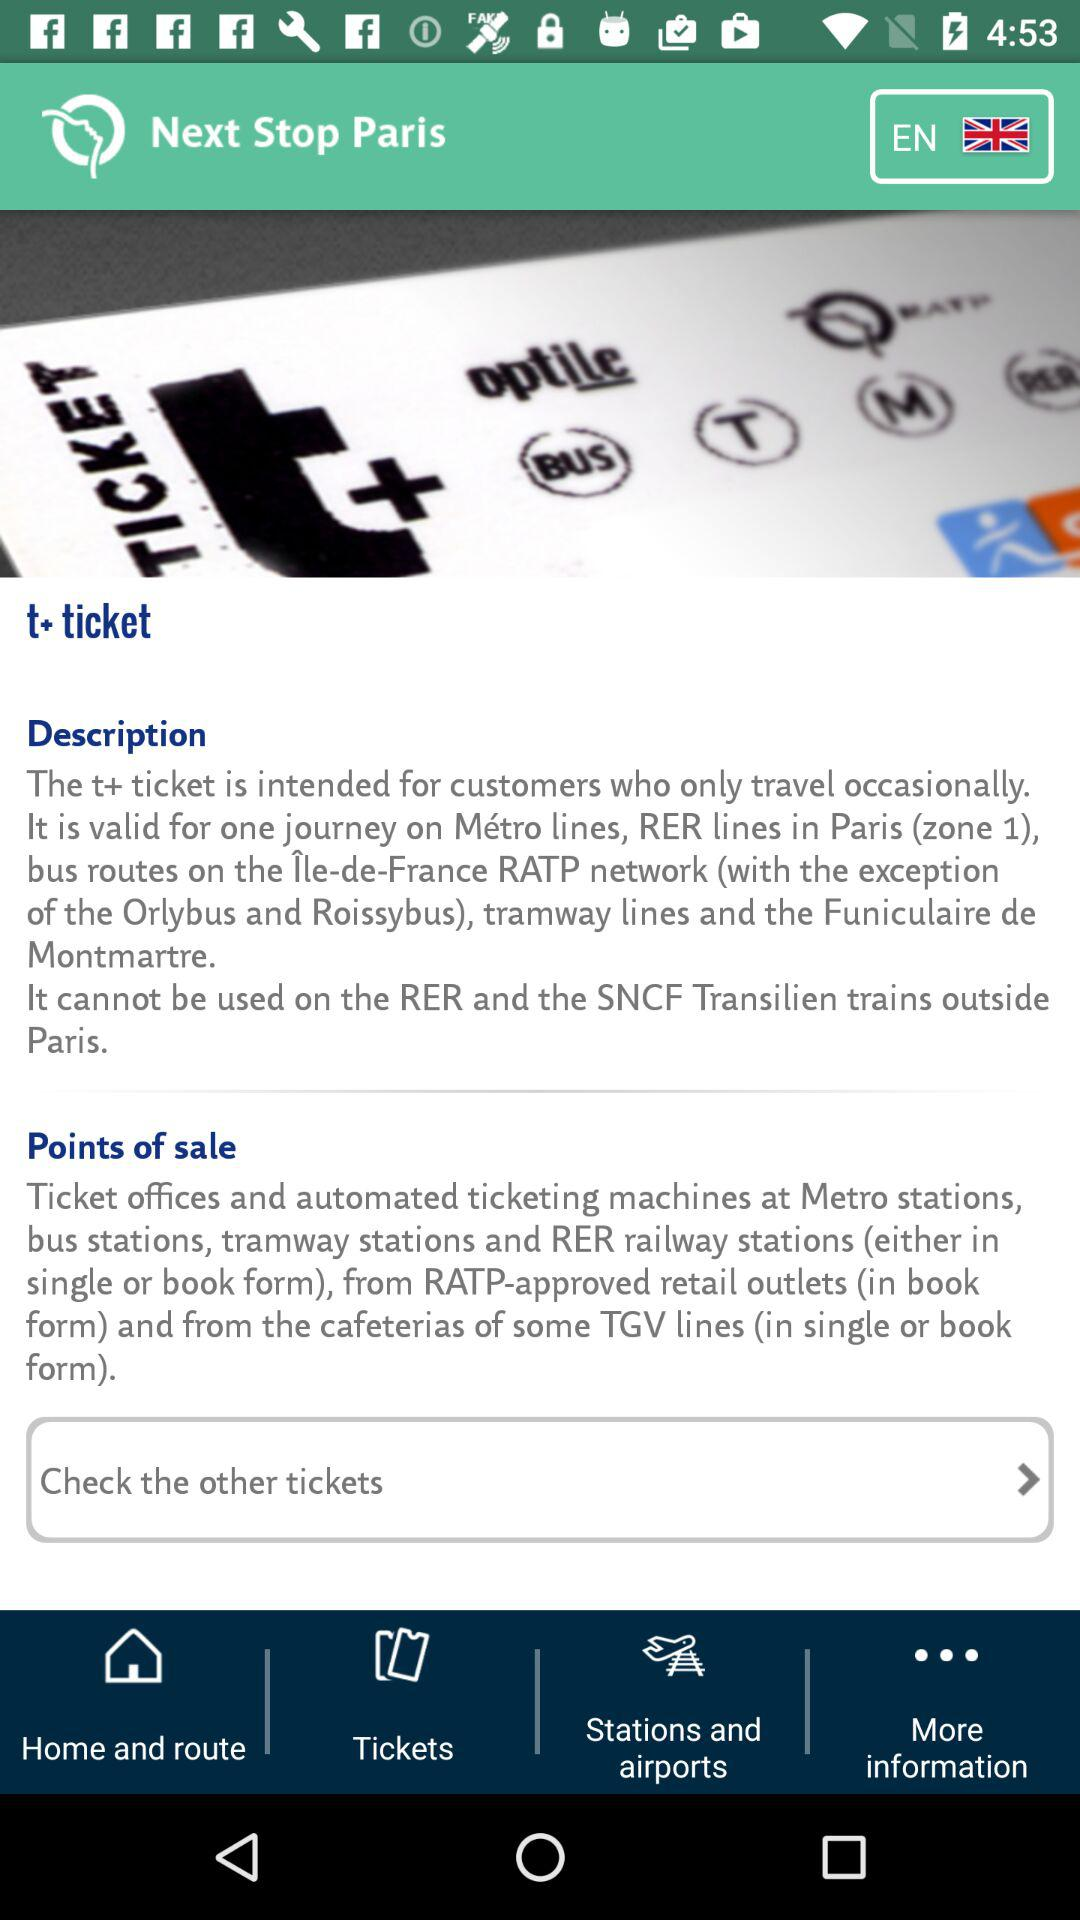What's the language? The language is English. 